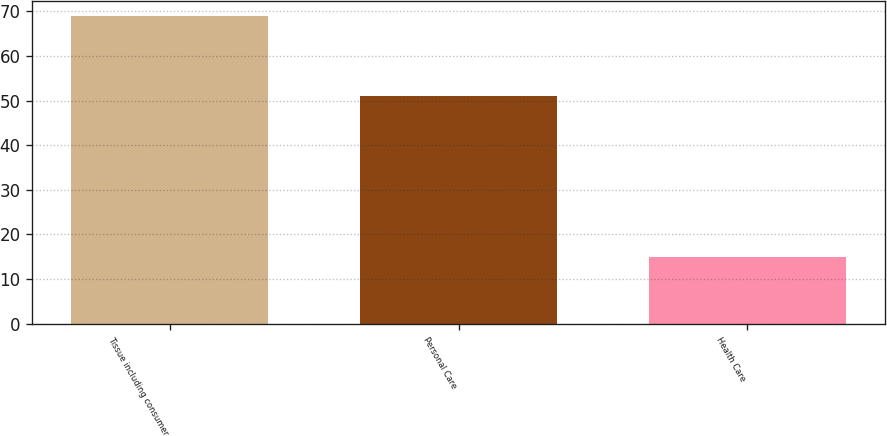Convert chart. <chart><loc_0><loc_0><loc_500><loc_500><bar_chart><fcel>Tissue including consumer<fcel>Personal Care<fcel>Health Care<nl><fcel>69<fcel>51<fcel>15<nl></chart> 